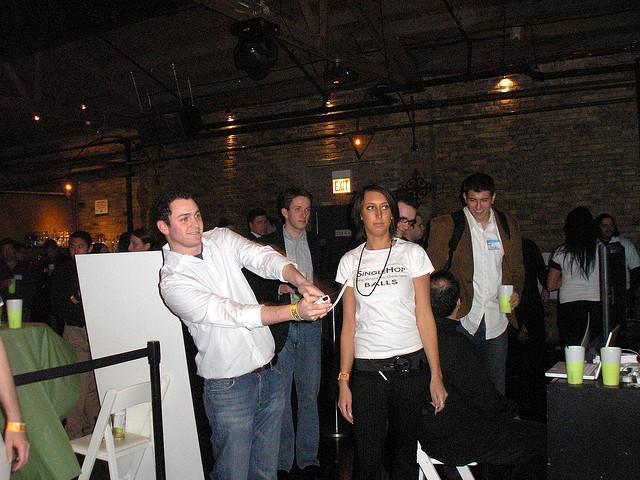Why is the man swinging his arm?
Choose the correct response and explain in the format: 'Answer: answer
Rationale: rationale.'
Options: To wave, to hit, to exercise, to control. Answer: to control.
Rationale: The man is playing a nintendo wii. the controller he's holding controls the nintendo wii. 